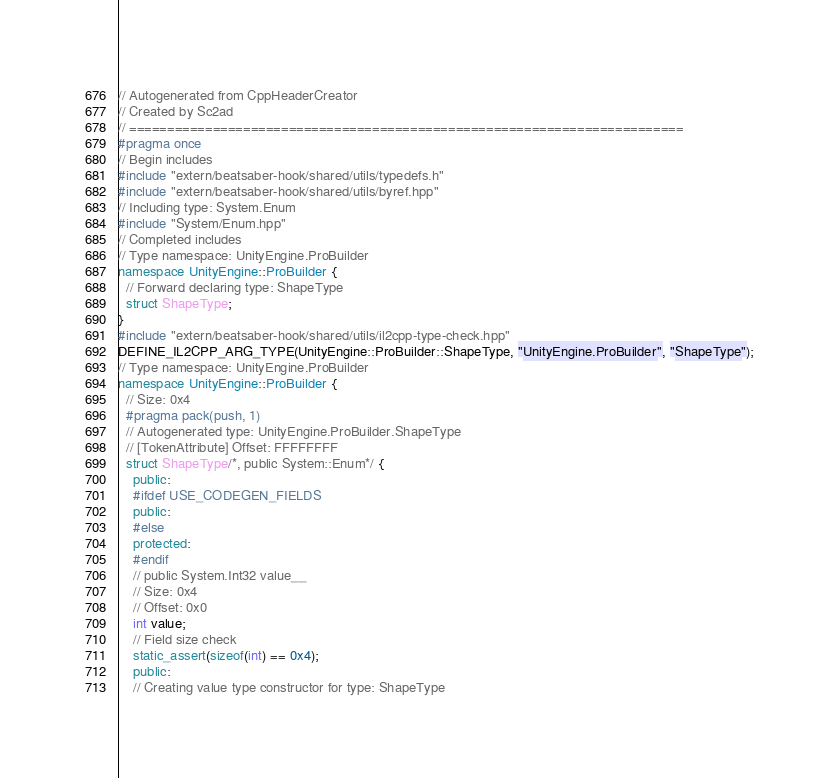Convert code to text. <code><loc_0><loc_0><loc_500><loc_500><_C++_>// Autogenerated from CppHeaderCreator
// Created by Sc2ad
// =========================================================================
#pragma once
// Begin includes
#include "extern/beatsaber-hook/shared/utils/typedefs.h"
#include "extern/beatsaber-hook/shared/utils/byref.hpp"
// Including type: System.Enum
#include "System/Enum.hpp"
// Completed includes
// Type namespace: UnityEngine.ProBuilder
namespace UnityEngine::ProBuilder {
  // Forward declaring type: ShapeType
  struct ShapeType;
}
#include "extern/beatsaber-hook/shared/utils/il2cpp-type-check.hpp"
DEFINE_IL2CPP_ARG_TYPE(UnityEngine::ProBuilder::ShapeType, "UnityEngine.ProBuilder", "ShapeType");
// Type namespace: UnityEngine.ProBuilder
namespace UnityEngine::ProBuilder {
  // Size: 0x4
  #pragma pack(push, 1)
  // Autogenerated type: UnityEngine.ProBuilder.ShapeType
  // [TokenAttribute] Offset: FFFFFFFF
  struct ShapeType/*, public System::Enum*/ {
    public:
    #ifdef USE_CODEGEN_FIELDS
    public:
    #else
    protected:
    #endif
    // public System.Int32 value__
    // Size: 0x4
    // Offset: 0x0
    int value;
    // Field size check
    static_assert(sizeof(int) == 0x4);
    public:
    // Creating value type constructor for type: ShapeType</code> 